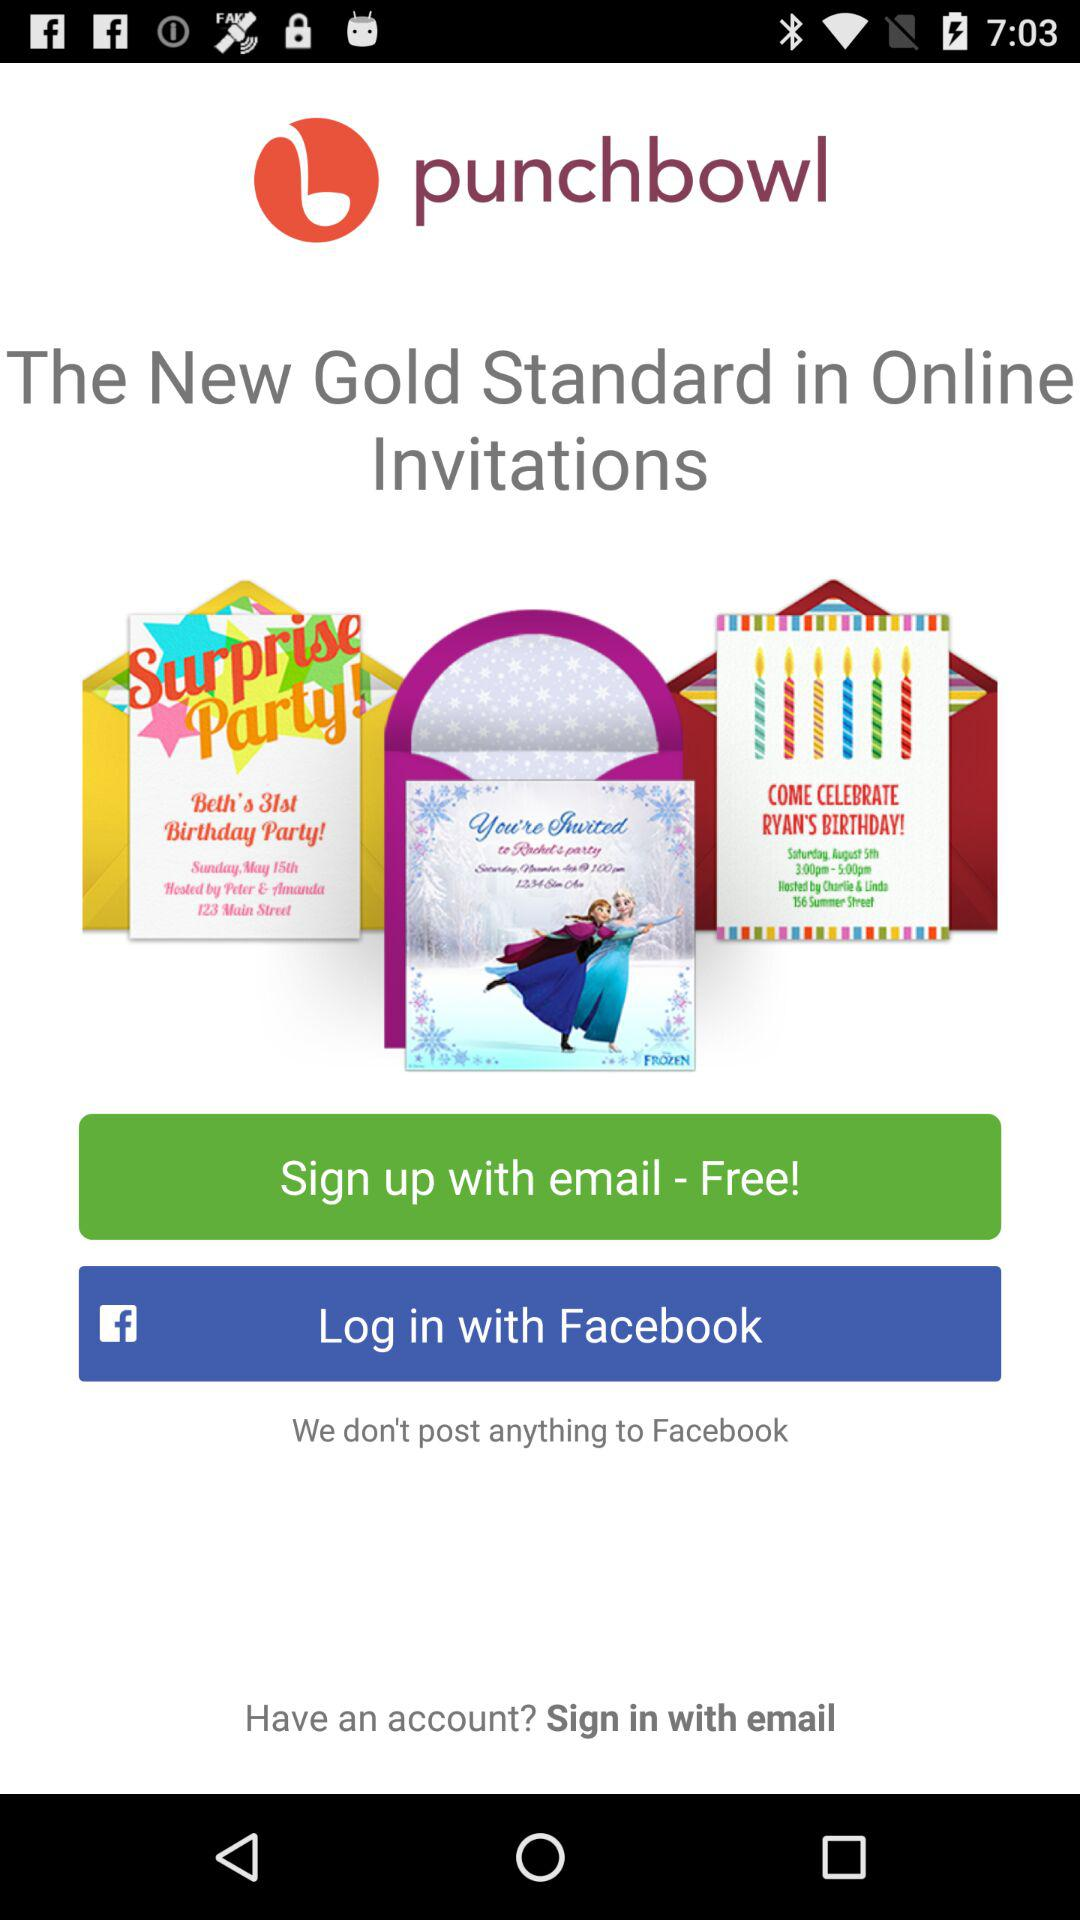What is the name of the application? The name of the application is "punchbowl". 